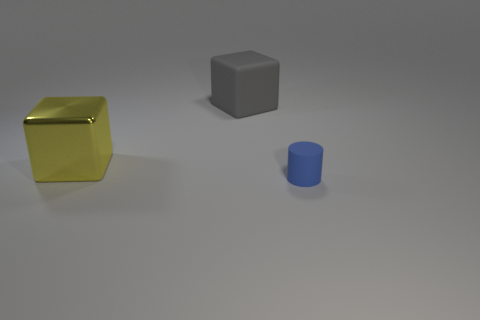How many yellow metallic objects are there? There is one yellow metallic object in the image, which appears to be a reflective cube situated on the left. 